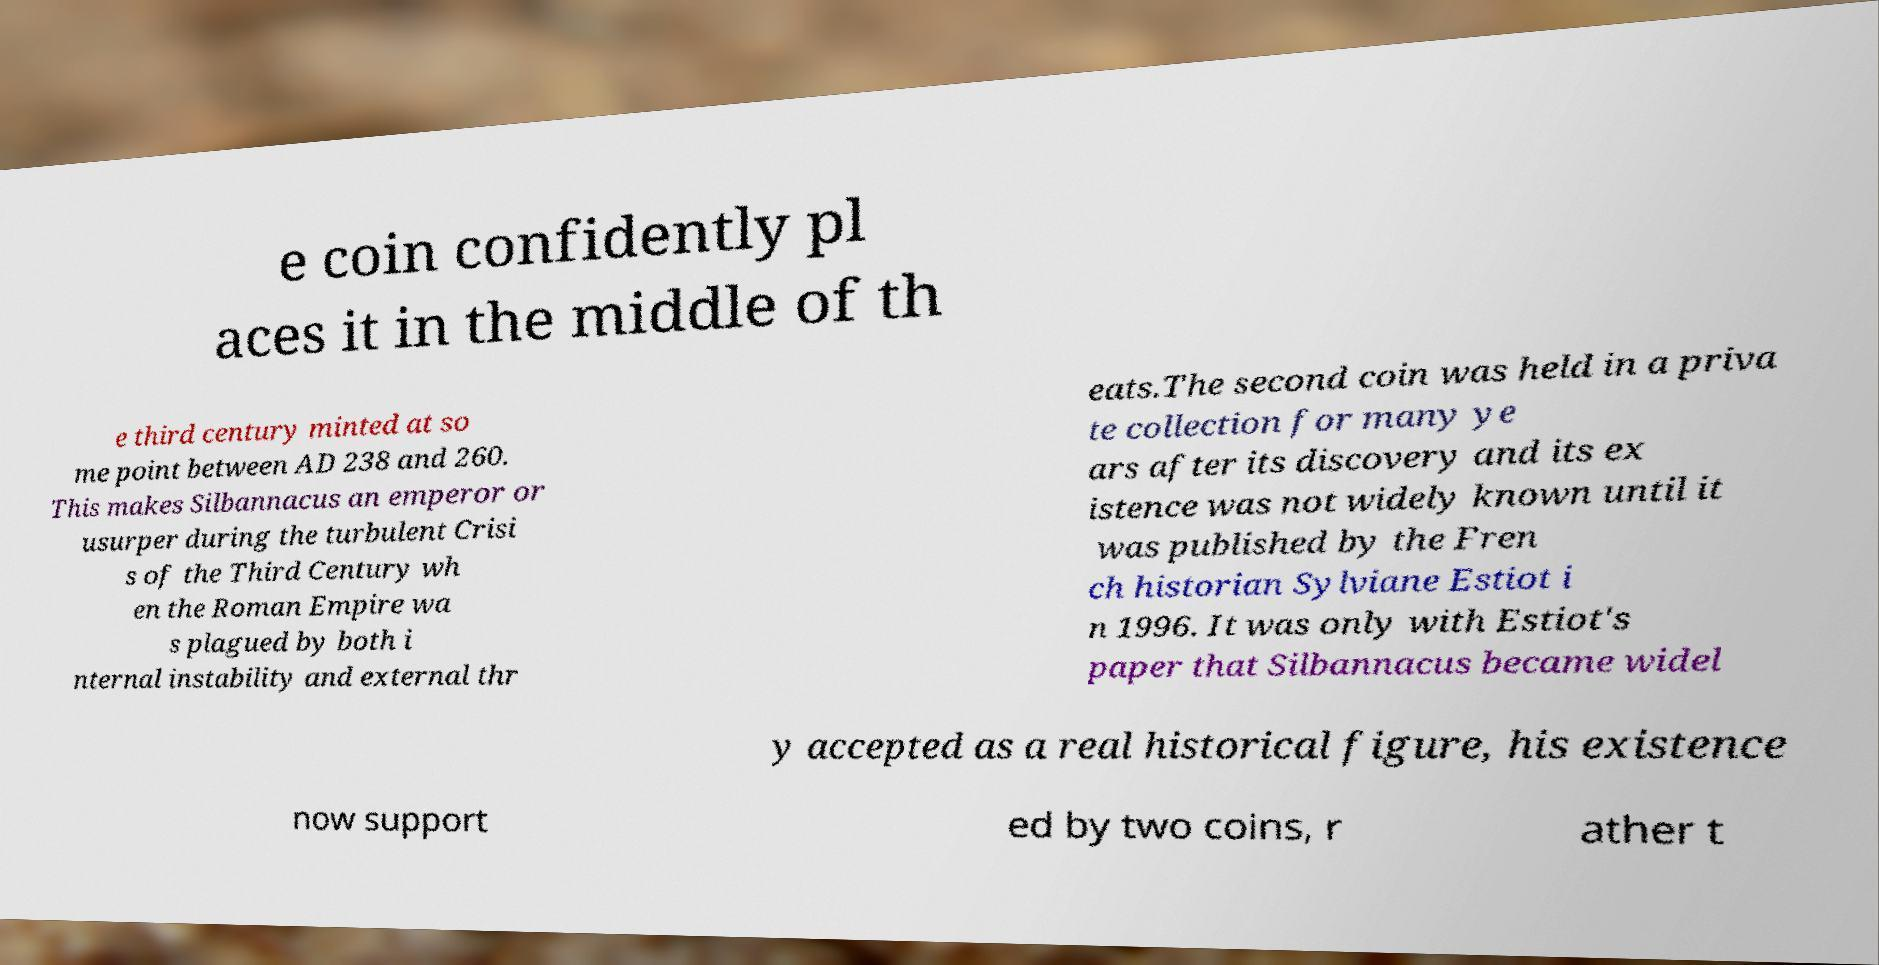I need the written content from this picture converted into text. Can you do that? e coin confidently pl aces it in the middle of th e third century minted at so me point between AD 238 and 260. This makes Silbannacus an emperor or usurper during the turbulent Crisi s of the Third Century wh en the Roman Empire wa s plagued by both i nternal instability and external thr eats.The second coin was held in a priva te collection for many ye ars after its discovery and its ex istence was not widely known until it was published by the Fren ch historian Sylviane Estiot i n 1996. It was only with Estiot's paper that Silbannacus became widel y accepted as a real historical figure, his existence now support ed by two coins, r ather t 